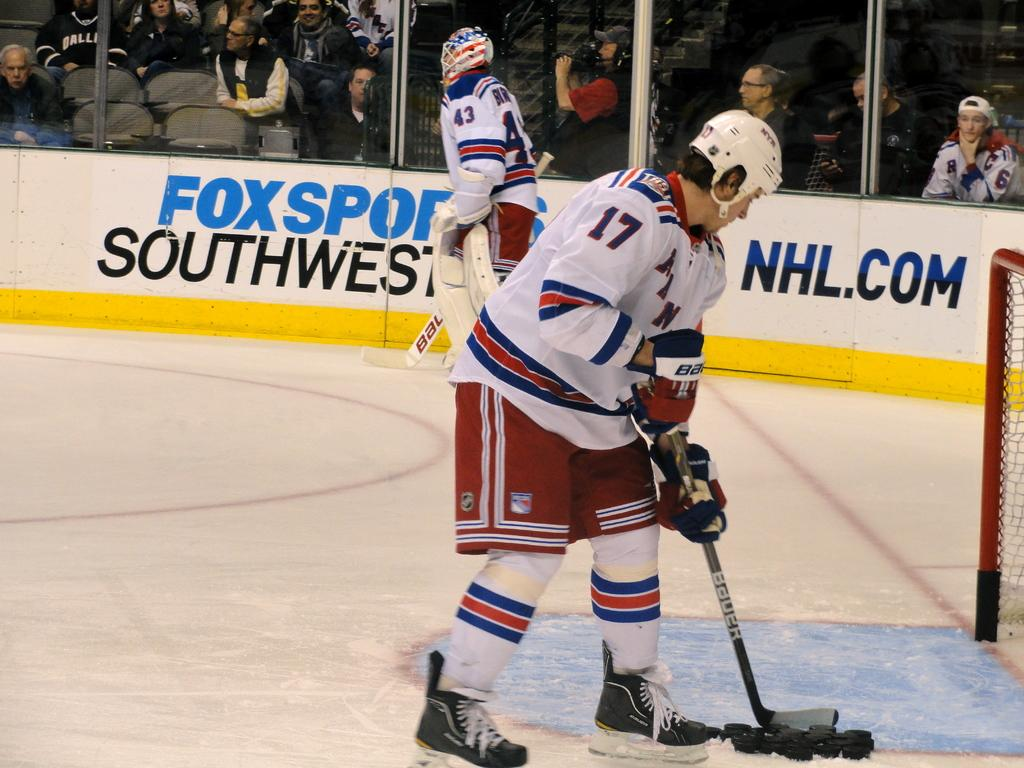Provide a one-sentence caption for the provided image. A hockey game is going on at the Fox Sports Southwest stadium. 